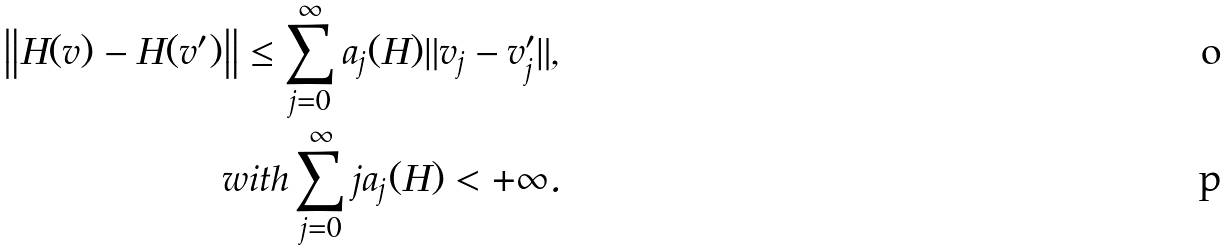<formula> <loc_0><loc_0><loc_500><loc_500>\left \| H ( v ) - H ( v ^ { \prime } ) \right \| \leq \sum _ { j = 0 } ^ { \infty } a _ { j } ( H ) \| v _ { j } - v ^ { \prime } _ { j } \| , \\ w i t h \sum _ { j = 0 } ^ { \infty } j a _ { j } ( H ) < + \infty .</formula> 